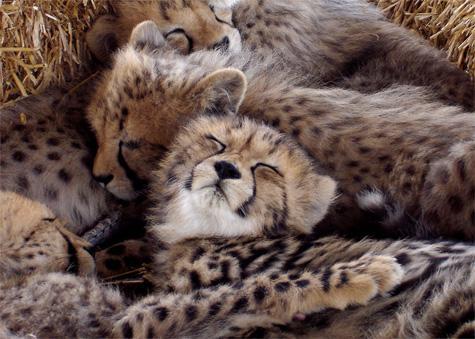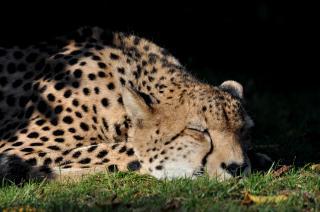The first image is the image on the left, the second image is the image on the right. Assess this claim about the two images: "Each image shows a single cheetah.". Correct or not? Answer yes or no. No. The first image is the image on the left, the second image is the image on the right. Examine the images to the left and right. Is the description "There are at most 2 cheetahs in the image pair" accurate? Answer yes or no. No. 